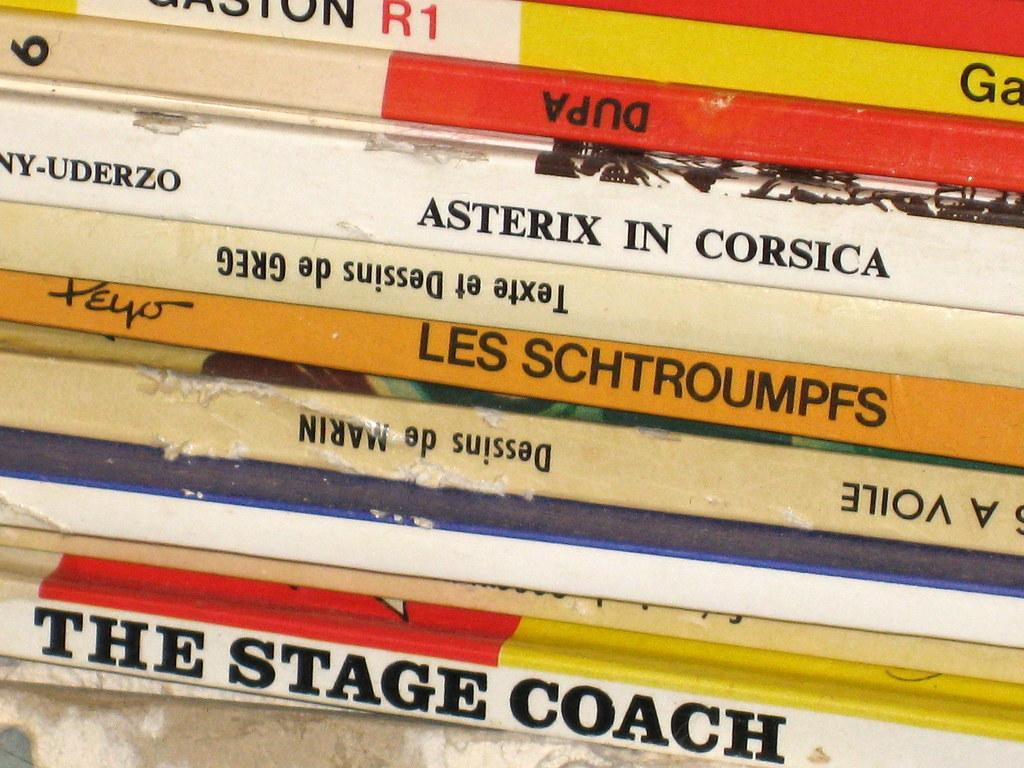<image>
Give a short and clear explanation of the subsequent image. Many books stacked and one of them is titled the stage coach 